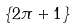<formula> <loc_0><loc_0><loc_500><loc_500>\{ 2 \pi + 1 \}</formula> 